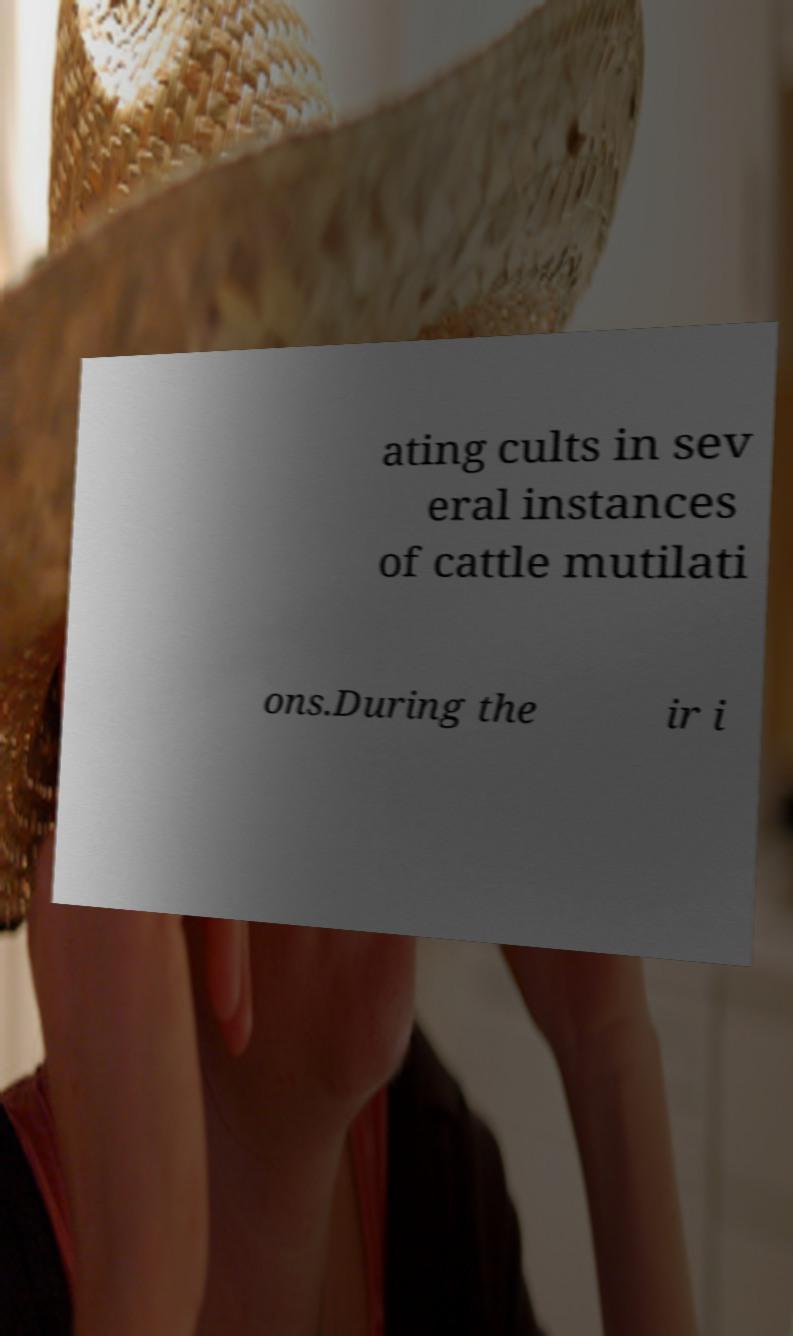Could you assist in decoding the text presented in this image and type it out clearly? ating cults in sev eral instances of cattle mutilati ons.During the ir i 